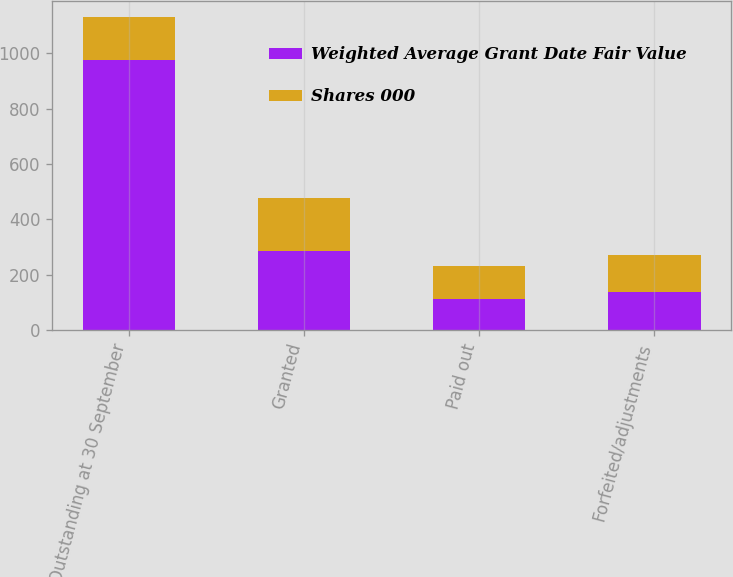<chart> <loc_0><loc_0><loc_500><loc_500><stacked_bar_chart><ecel><fcel>Outstanding at 30 September<fcel>Granted<fcel>Paid out<fcel>Forfeited/adjustments<nl><fcel>Weighted Average Grant Date Fair Value<fcel>976<fcel>285<fcel>113<fcel>136<nl><fcel>Shares 000<fcel>156.31<fcel>193.29<fcel>119.59<fcel>136.11<nl></chart> 